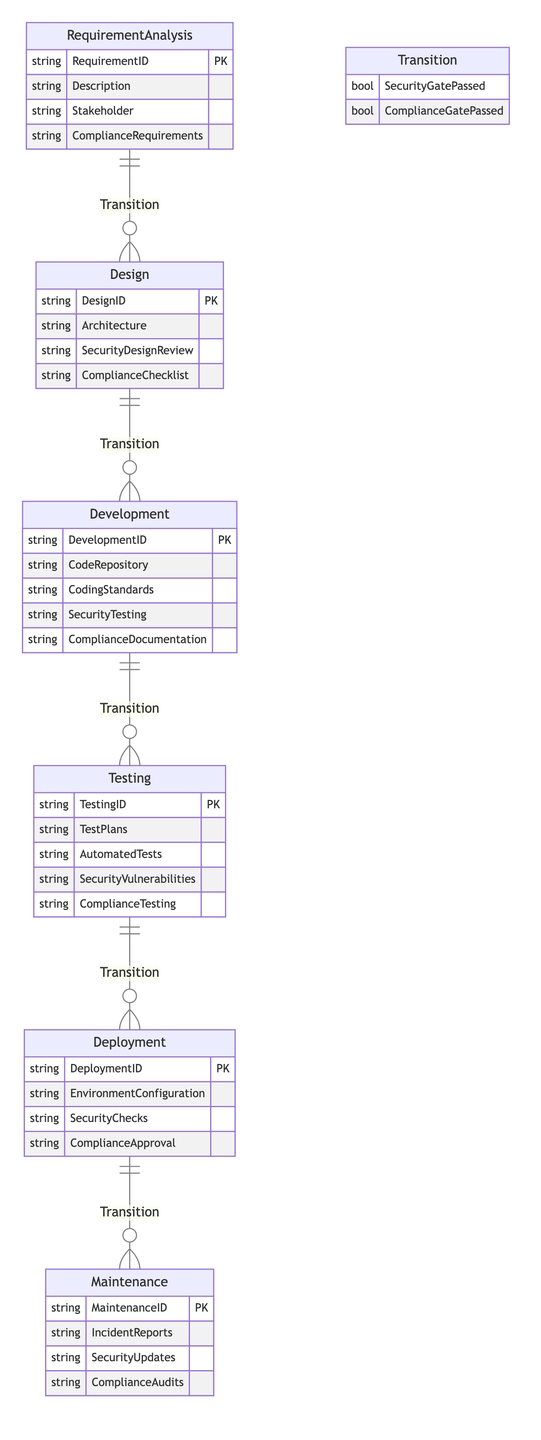What is the primary key of the RequirementAnalysis entity? The primary key of the RequirementAnalysis entity is the attribute labeled RequirementID. This is indicated by the notation 'PK' following the attribute in the diagram.
Answer: RequirementID How many entities are there in the diagram? The diagram lists a total of six entities: RequirementAnalysis, Design, Development, Testing, Deployment, and Maintenance. Counting each entity gives us the total number.
Answer: 6 What relationship exists between Testing and Deployment? The relationship between Testing and Deployment is defined as "Transition." This means that they are connected and there is a specific flow from Testing to Deployment.
Answer: Transition Which entity has the attribute SecurityChecks? The attribute SecurityChecks is part of the Deployment entity. This is present in the list of attributes associated with the Deployment entity in the diagram.
Answer: Deployment How many transitions are there in total? There are five transitions depicted between the entities in the diagram, calculated by counting the transitions specified between each pair of connected entities.
Answer: 5 What are the attributes of the Design entity? The attributes of the Design entity include DesignID, Architecture, SecurityDesignReview, and ComplianceChecklist. These are explicitly listed under the Design entity in the diagram.
Answer: DesignID, Architecture, SecurityDesignReview, ComplianceChecklist Which phase must pass the ComplianceGate to move to the Testing phase? The Development phase must pass the ComplianceGate in order to transition to the Testing phase. This sequence is shown in the transition relationship from Development to Testing.
Answer: Development In which phase are SecurityUpdates documented? SecurityUpdates are documented in the Maintenance phase. This is identified by the attribute listed under the Maintenance entity in the diagram.
Answer: Maintenance What attribute indicates a successful transition from Development to Testing? The attribute indicating a successful transition from Development to Testing is SecurityGatePassed. This attribute is part of the relationship between these two entities.
Answer: SecurityGatePassed 